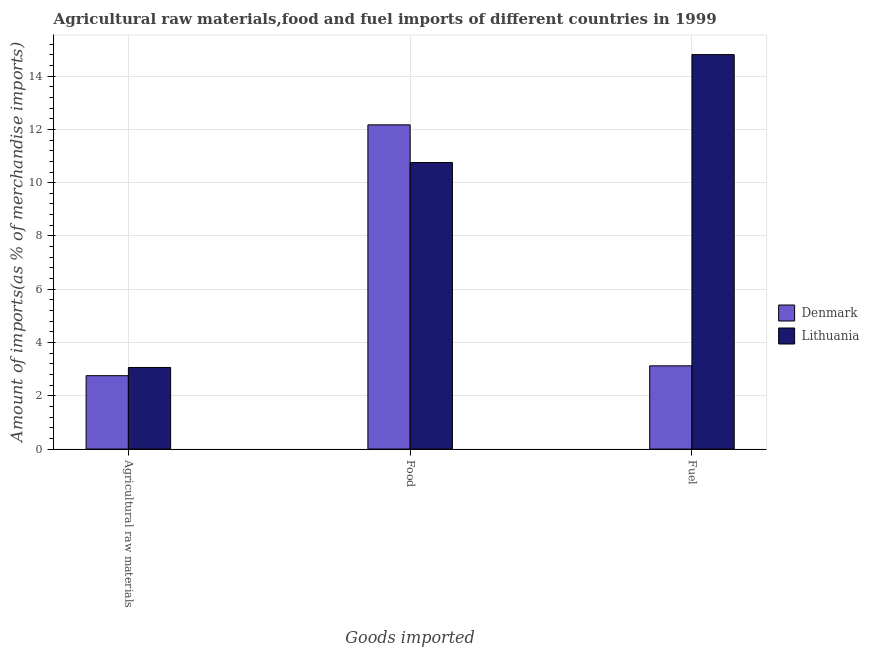How many different coloured bars are there?
Ensure brevity in your answer.  2. How many groups of bars are there?
Ensure brevity in your answer.  3. How many bars are there on the 2nd tick from the left?
Keep it short and to the point. 2. How many bars are there on the 2nd tick from the right?
Provide a short and direct response. 2. What is the label of the 2nd group of bars from the left?
Your answer should be very brief. Food. What is the percentage of food imports in Lithuania?
Provide a short and direct response. 10.76. Across all countries, what is the maximum percentage of raw materials imports?
Make the answer very short. 3.06. Across all countries, what is the minimum percentage of raw materials imports?
Your response must be concise. 2.76. In which country was the percentage of fuel imports maximum?
Offer a terse response. Lithuania. In which country was the percentage of food imports minimum?
Give a very brief answer. Lithuania. What is the total percentage of food imports in the graph?
Make the answer very short. 22.93. What is the difference between the percentage of food imports in Lithuania and that in Denmark?
Offer a terse response. -1.41. What is the difference between the percentage of food imports in Lithuania and the percentage of raw materials imports in Denmark?
Provide a succinct answer. 8. What is the average percentage of raw materials imports per country?
Ensure brevity in your answer.  2.91. What is the difference between the percentage of raw materials imports and percentage of food imports in Denmark?
Ensure brevity in your answer.  -9.42. What is the ratio of the percentage of raw materials imports in Lithuania to that in Denmark?
Give a very brief answer. 1.11. Is the difference between the percentage of raw materials imports in Lithuania and Denmark greater than the difference between the percentage of food imports in Lithuania and Denmark?
Your answer should be compact. Yes. What is the difference between the highest and the second highest percentage of fuel imports?
Ensure brevity in your answer.  11.68. What is the difference between the highest and the lowest percentage of food imports?
Offer a terse response. 1.41. In how many countries, is the percentage of raw materials imports greater than the average percentage of raw materials imports taken over all countries?
Provide a short and direct response. 1. Is the sum of the percentage of food imports in Denmark and Lithuania greater than the maximum percentage of fuel imports across all countries?
Offer a very short reply. Yes. What does the 2nd bar from the right in Fuel represents?
Offer a terse response. Denmark. Are all the bars in the graph horizontal?
Your answer should be compact. No. What is the difference between two consecutive major ticks on the Y-axis?
Ensure brevity in your answer.  2. Are the values on the major ticks of Y-axis written in scientific E-notation?
Your answer should be compact. No. Does the graph contain any zero values?
Your answer should be compact. No. Does the graph contain grids?
Your answer should be compact. Yes. What is the title of the graph?
Provide a succinct answer. Agricultural raw materials,food and fuel imports of different countries in 1999. What is the label or title of the X-axis?
Offer a terse response. Goods imported. What is the label or title of the Y-axis?
Your answer should be very brief. Amount of imports(as % of merchandise imports). What is the Amount of imports(as % of merchandise imports) in Denmark in Agricultural raw materials?
Make the answer very short. 2.76. What is the Amount of imports(as % of merchandise imports) in Lithuania in Agricultural raw materials?
Give a very brief answer. 3.06. What is the Amount of imports(as % of merchandise imports) of Denmark in Food?
Provide a short and direct response. 12.17. What is the Amount of imports(as % of merchandise imports) of Lithuania in Food?
Ensure brevity in your answer.  10.76. What is the Amount of imports(as % of merchandise imports) of Denmark in Fuel?
Give a very brief answer. 3.12. What is the Amount of imports(as % of merchandise imports) in Lithuania in Fuel?
Make the answer very short. 14.81. Across all Goods imported, what is the maximum Amount of imports(as % of merchandise imports) of Denmark?
Your response must be concise. 12.17. Across all Goods imported, what is the maximum Amount of imports(as % of merchandise imports) of Lithuania?
Your answer should be compact. 14.81. Across all Goods imported, what is the minimum Amount of imports(as % of merchandise imports) of Denmark?
Keep it short and to the point. 2.76. Across all Goods imported, what is the minimum Amount of imports(as % of merchandise imports) in Lithuania?
Keep it short and to the point. 3.06. What is the total Amount of imports(as % of merchandise imports) of Denmark in the graph?
Your answer should be compact. 18.05. What is the total Amount of imports(as % of merchandise imports) in Lithuania in the graph?
Your answer should be very brief. 28.63. What is the difference between the Amount of imports(as % of merchandise imports) of Denmark in Agricultural raw materials and that in Food?
Your answer should be very brief. -9.42. What is the difference between the Amount of imports(as % of merchandise imports) of Lithuania in Agricultural raw materials and that in Food?
Your response must be concise. -7.69. What is the difference between the Amount of imports(as % of merchandise imports) in Denmark in Agricultural raw materials and that in Fuel?
Ensure brevity in your answer.  -0.37. What is the difference between the Amount of imports(as % of merchandise imports) of Lithuania in Agricultural raw materials and that in Fuel?
Offer a very short reply. -11.74. What is the difference between the Amount of imports(as % of merchandise imports) in Denmark in Food and that in Fuel?
Provide a short and direct response. 9.05. What is the difference between the Amount of imports(as % of merchandise imports) of Lithuania in Food and that in Fuel?
Keep it short and to the point. -4.05. What is the difference between the Amount of imports(as % of merchandise imports) of Denmark in Agricultural raw materials and the Amount of imports(as % of merchandise imports) of Lithuania in Food?
Your answer should be very brief. -8. What is the difference between the Amount of imports(as % of merchandise imports) of Denmark in Agricultural raw materials and the Amount of imports(as % of merchandise imports) of Lithuania in Fuel?
Offer a terse response. -12.05. What is the difference between the Amount of imports(as % of merchandise imports) of Denmark in Food and the Amount of imports(as % of merchandise imports) of Lithuania in Fuel?
Keep it short and to the point. -2.64. What is the average Amount of imports(as % of merchandise imports) of Denmark per Goods imported?
Provide a succinct answer. 6.02. What is the average Amount of imports(as % of merchandise imports) in Lithuania per Goods imported?
Provide a short and direct response. 9.54. What is the difference between the Amount of imports(as % of merchandise imports) in Denmark and Amount of imports(as % of merchandise imports) in Lithuania in Agricultural raw materials?
Provide a succinct answer. -0.31. What is the difference between the Amount of imports(as % of merchandise imports) in Denmark and Amount of imports(as % of merchandise imports) in Lithuania in Food?
Offer a terse response. 1.41. What is the difference between the Amount of imports(as % of merchandise imports) of Denmark and Amount of imports(as % of merchandise imports) of Lithuania in Fuel?
Give a very brief answer. -11.68. What is the ratio of the Amount of imports(as % of merchandise imports) of Denmark in Agricultural raw materials to that in Food?
Offer a very short reply. 0.23. What is the ratio of the Amount of imports(as % of merchandise imports) of Lithuania in Agricultural raw materials to that in Food?
Your answer should be very brief. 0.28. What is the ratio of the Amount of imports(as % of merchandise imports) of Denmark in Agricultural raw materials to that in Fuel?
Your response must be concise. 0.88. What is the ratio of the Amount of imports(as % of merchandise imports) of Lithuania in Agricultural raw materials to that in Fuel?
Make the answer very short. 0.21. What is the ratio of the Amount of imports(as % of merchandise imports) in Denmark in Food to that in Fuel?
Your answer should be compact. 3.89. What is the ratio of the Amount of imports(as % of merchandise imports) in Lithuania in Food to that in Fuel?
Your answer should be compact. 0.73. What is the difference between the highest and the second highest Amount of imports(as % of merchandise imports) in Denmark?
Provide a short and direct response. 9.05. What is the difference between the highest and the second highest Amount of imports(as % of merchandise imports) in Lithuania?
Provide a short and direct response. 4.05. What is the difference between the highest and the lowest Amount of imports(as % of merchandise imports) of Denmark?
Make the answer very short. 9.42. What is the difference between the highest and the lowest Amount of imports(as % of merchandise imports) of Lithuania?
Make the answer very short. 11.74. 